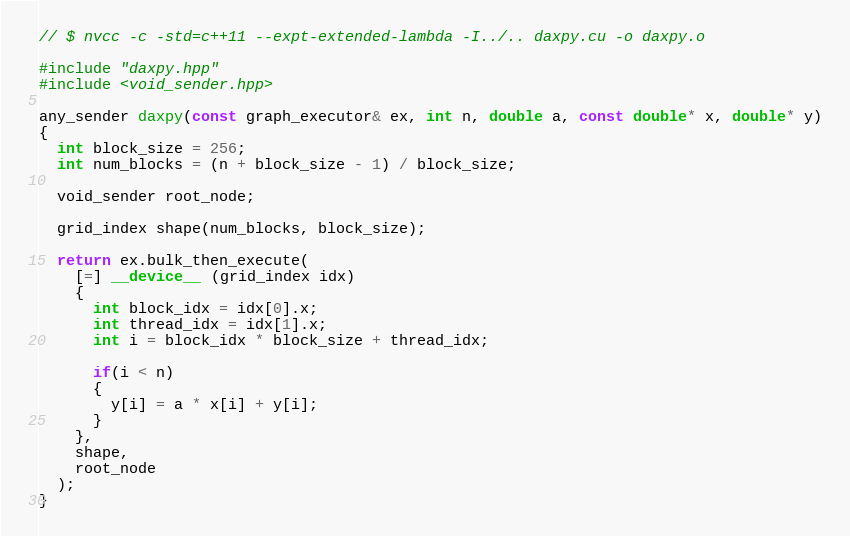<code> <loc_0><loc_0><loc_500><loc_500><_Cuda_>// $ nvcc -c -std=c++11 --expt-extended-lambda -I../.. daxpy.cu -o daxpy.o

#include "daxpy.hpp"
#include <void_sender.hpp>

any_sender daxpy(const graph_executor& ex, int n, double a, const double* x, double* y)
{
  int block_size = 256;
  int num_blocks = (n + block_size - 1) / block_size;

  void_sender root_node;

  grid_index shape(num_blocks, block_size);

  return ex.bulk_then_execute(
    [=] __device__ (grid_index idx)
    {
      int block_idx = idx[0].x;
      int thread_idx = idx[1].x;
      int i = block_idx * block_size + thread_idx;

      if(i < n)
      {
        y[i] = a * x[i] + y[i];
      }
    },
    shape,
    root_node
  );
}

</code> 